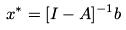Convert formula to latex. <formula><loc_0><loc_0><loc_500><loc_500>x ^ { * } = [ I - A ] ^ { - 1 } b</formula> 